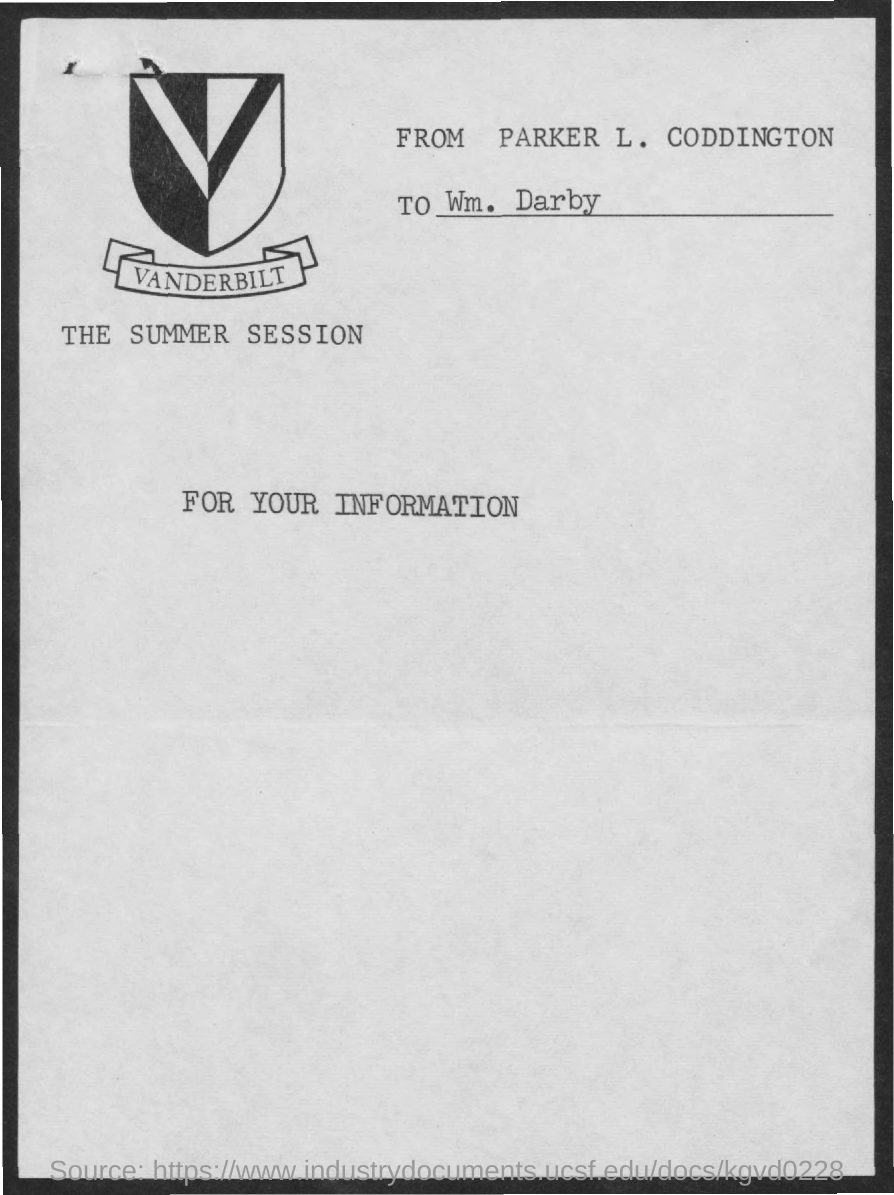To whom, the document is addressed?
Provide a short and direct response. Wm. Darby. Who is the sender?
Your response must be concise. PARKER L. CODDINGTON. Which university's icon is shown here?
Provide a short and direct response. VANDERBILT. 